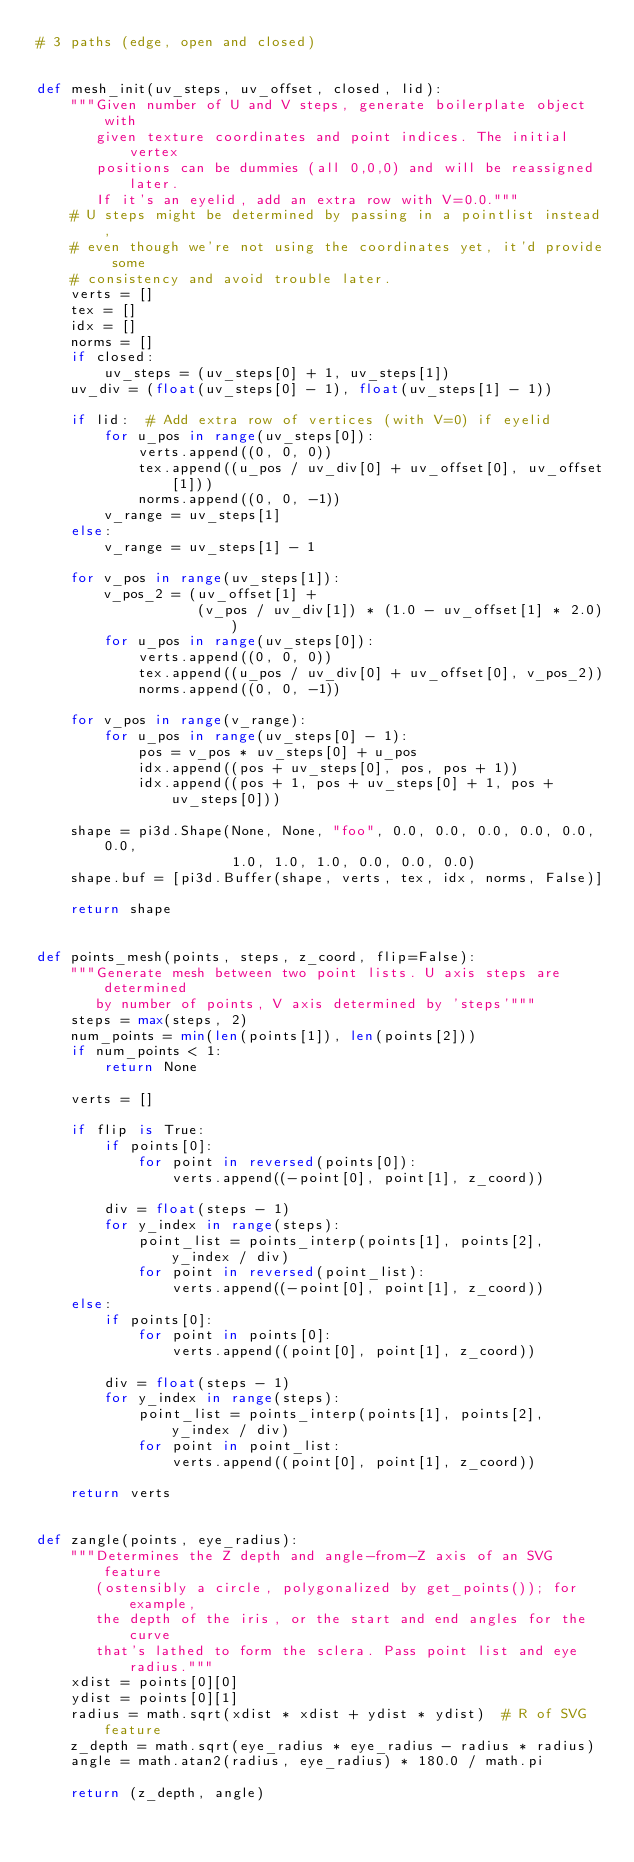<code> <loc_0><loc_0><loc_500><loc_500><_Python_># 3 paths (edge, open and closed)


def mesh_init(uv_steps, uv_offset, closed, lid):
    """Given number of U and V steps, generate boilerplate object with
       given texture coordinates and point indices. The initial vertex
       positions can be dummies (all 0,0,0) and will be reassigned later.
       If it's an eyelid, add an extra row with V=0.0."""
    # U steps might be determined by passing in a pointlist instead,
    # even though we're not using the coordinates yet, it'd provide some
    # consistency and avoid trouble later.
    verts = []
    tex = []
    idx = []
    norms = []
    if closed:
        uv_steps = (uv_steps[0] + 1, uv_steps[1])
    uv_div = (float(uv_steps[0] - 1), float(uv_steps[1] - 1))

    if lid:  # Add extra row of vertices (with V=0) if eyelid
        for u_pos in range(uv_steps[0]):
            verts.append((0, 0, 0))
            tex.append((u_pos / uv_div[0] + uv_offset[0], uv_offset[1]))
            norms.append((0, 0, -1))
        v_range = uv_steps[1]
    else:
        v_range = uv_steps[1] - 1

    for v_pos in range(uv_steps[1]):
        v_pos_2 = (uv_offset[1] +
                   (v_pos / uv_div[1]) * (1.0 - uv_offset[1] * 2.0))
        for u_pos in range(uv_steps[0]):
            verts.append((0, 0, 0))
            tex.append((u_pos / uv_div[0] + uv_offset[0], v_pos_2))
            norms.append((0, 0, -1))

    for v_pos in range(v_range):
        for u_pos in range(uv_steps[0] - 1):
            pos = v_pos * uv_steps[0] + u_pos
            idx.append((pos + uv_steps[0], pos, pos + 1))
            idx.append((pos + 1, pos + uv_steps[0] + 1, pos + uv_steps[0]))

    shape = pi3d.Shape(None, None, "foo", 0.0, 0.0, 0.0, 0.0, 0.0, 0.0,
                       1.0, 1.0, 1.0, 0.0, 0.0, 0.0)
    shape.buf = [pi3d.Buffer(shape, verts, tex, idx, norms, False)]

    return shape


def points_mesh(points, steps, z_coord, flip=False):
    """Generate mesh between two point lists. U axis steps are determined
       by number of points, V axis determined by 'steps'"""
    steps = max(steps, 2)
    num_points = min(len(points[1]), len(points[2]))
    if num_points < 1:
        return None

    verts = []

    if flip is True:
        if points[0]:
            for point in reversed(points[0]):
                verts.append((-point[0], point[1], z_coord))

        div = float(steps - 1)
        for y_index in range(steps):
            point_list = points_interp(points[1], points[2], y_index / div)
            for point in reversed(point_list):
                verts.append((-point[0], point[1], z_coord))
    else:
        if points[0]:
            for point in points[0]:
                verts.append((point[0], point[1], z_coord))

        div = float(steps - 1)
        for y_index in range(steps):
            point_list = points_interp(points[1], points[2], y_index / div)
            for point in point_list:
                verts.append((point[0], point[1], z_coord))

    return verts


def zangle(points, eye_radius):
    """Determines the Z depth and angle-from-Z axis of an SVG feature
       (ostensibly a circle, polygonalized by get_points()); for example,
       the depth of the iris, or the start and end angles for the curve
       that's lathed to form the sclera. Pass point list and eye radius."""
    xdist = points[0][0]
    ydist = points[0][1]
    radius = math.sqrt(xdist * xdist + ydist * ydist)  # R of SVG feature
    z_depth = math.sqrt(eye_radius * eye_radius - radius * radius)
    angle = math.atan2(radius, eye_radius) * 180.0 / math.pi

    return (z_depth, angle)
</code> 